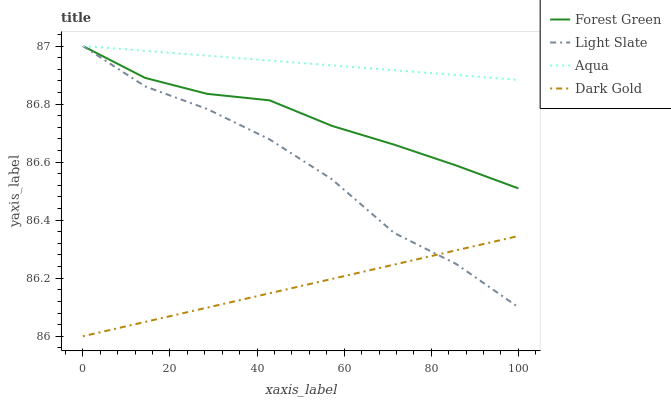Does Forest Green have the minimum area under the curve?
Answer yes or no. No. Does Forest Green have the maximum area under the curve?
Answer yes or no. No. Is Forest Green the smoothest?
Answer yes or no. No. Is Forest Green the roughest?
Answer yes or no. No. Does Forest Green have the lowest value?
Answer yes or no. No. Does Dark Gold have the highest value?
Answer yes or no. No. Is Dark Gold less than Forest Green?
Answer yes or no. Yes. Is Forest Green greater than Dark Gold?
Answer yes or no. Yes. Does Dark Gold intersect Forest Green?
Answer yes or no. No. 